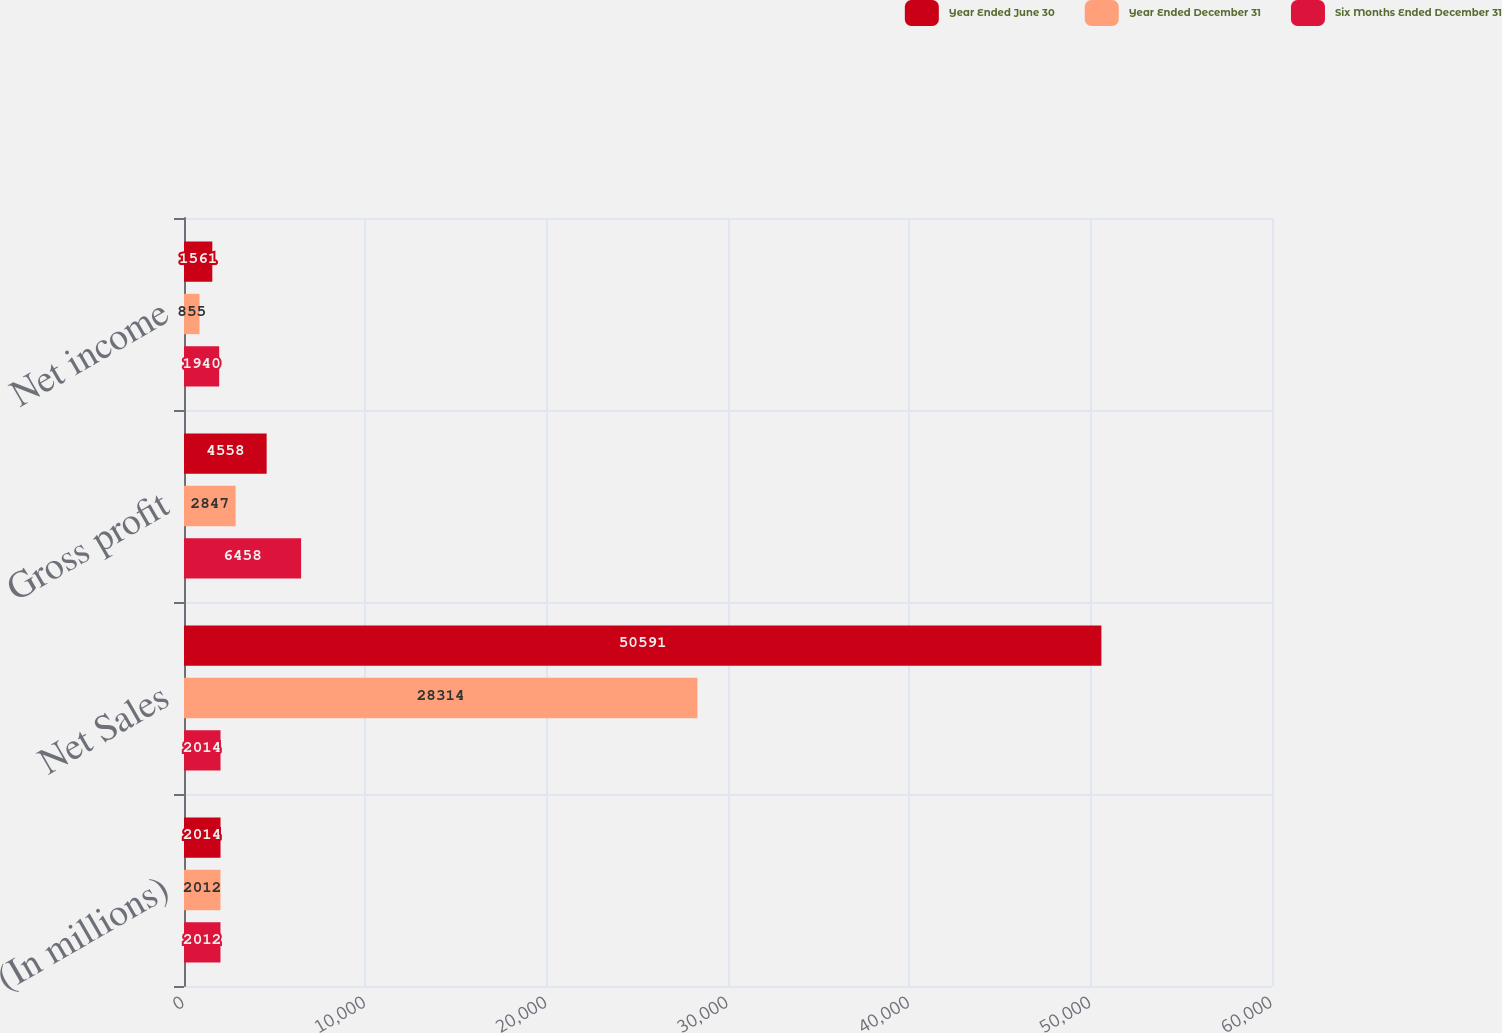Convert chart to OTSL. <chart><loc_0><loc_0><loc_500><loc_500><stacked_bar_chart><ecel><fcel>(In millions)<fcel>Net Sales<fcel>Gross profit<fcel>Net income<nl><fcel>Year Ended June 30<fcel>2014<fcel>50591<fcel>4558<fcel>1561<nl><fcel>Year Ended December 31<fcel>2012<fcel>28314<fcel>2847<fcel>855<nl><fcel>Six Months Ended December 31<fcel>2012<fcel>2014<fcel>6458<fcel>1940<nl></chart> 